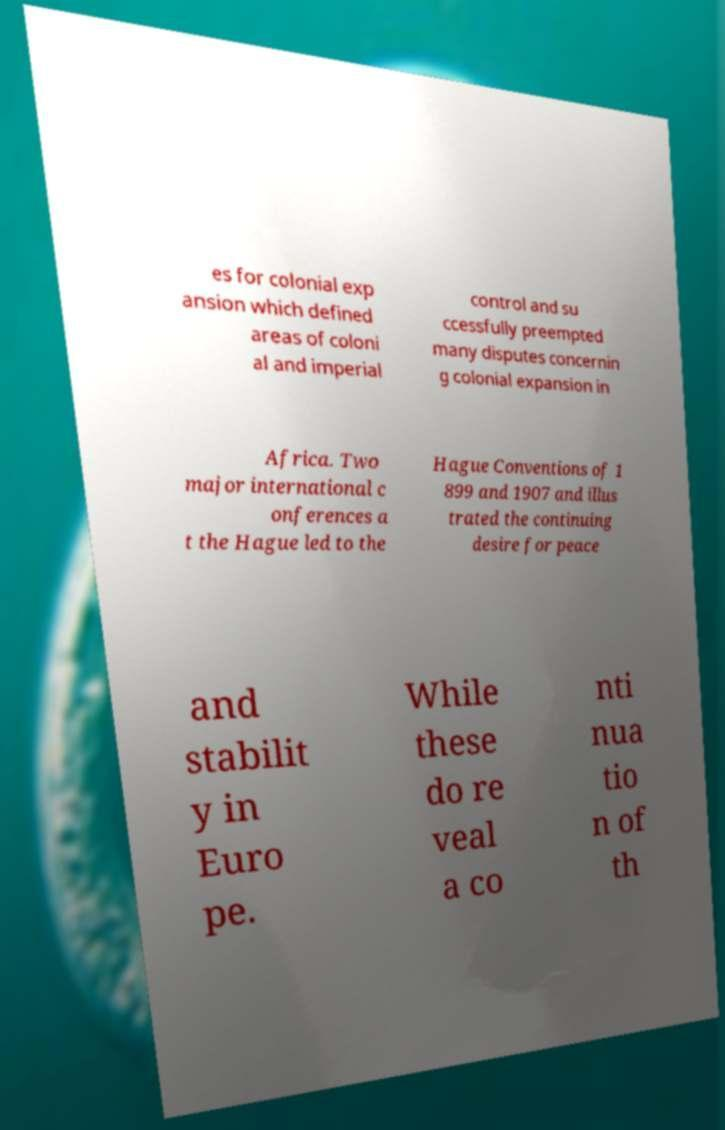Can you accurately transcribe the text from the provided image for me? es for colonial exp ansion which defined areas of coloni al and imperial control and su ccessfully preempted many disputes concernin g colonial expansion in Africa. Two major international c onferences a t the Hague led to the Hague Conventions of 1 899 and 1907 and illus trated the continuing desire for peace and stabilit y in Euro pe. While these do re veal a co nti nua tio n of th 